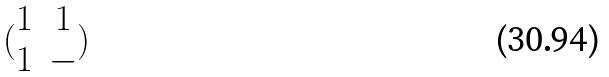<formula> <loc_0><loc_0><loc_500><loc_500>( \begin{matrix} 1 & 1 \\ 1 & - \end{matrix} )</formula> 